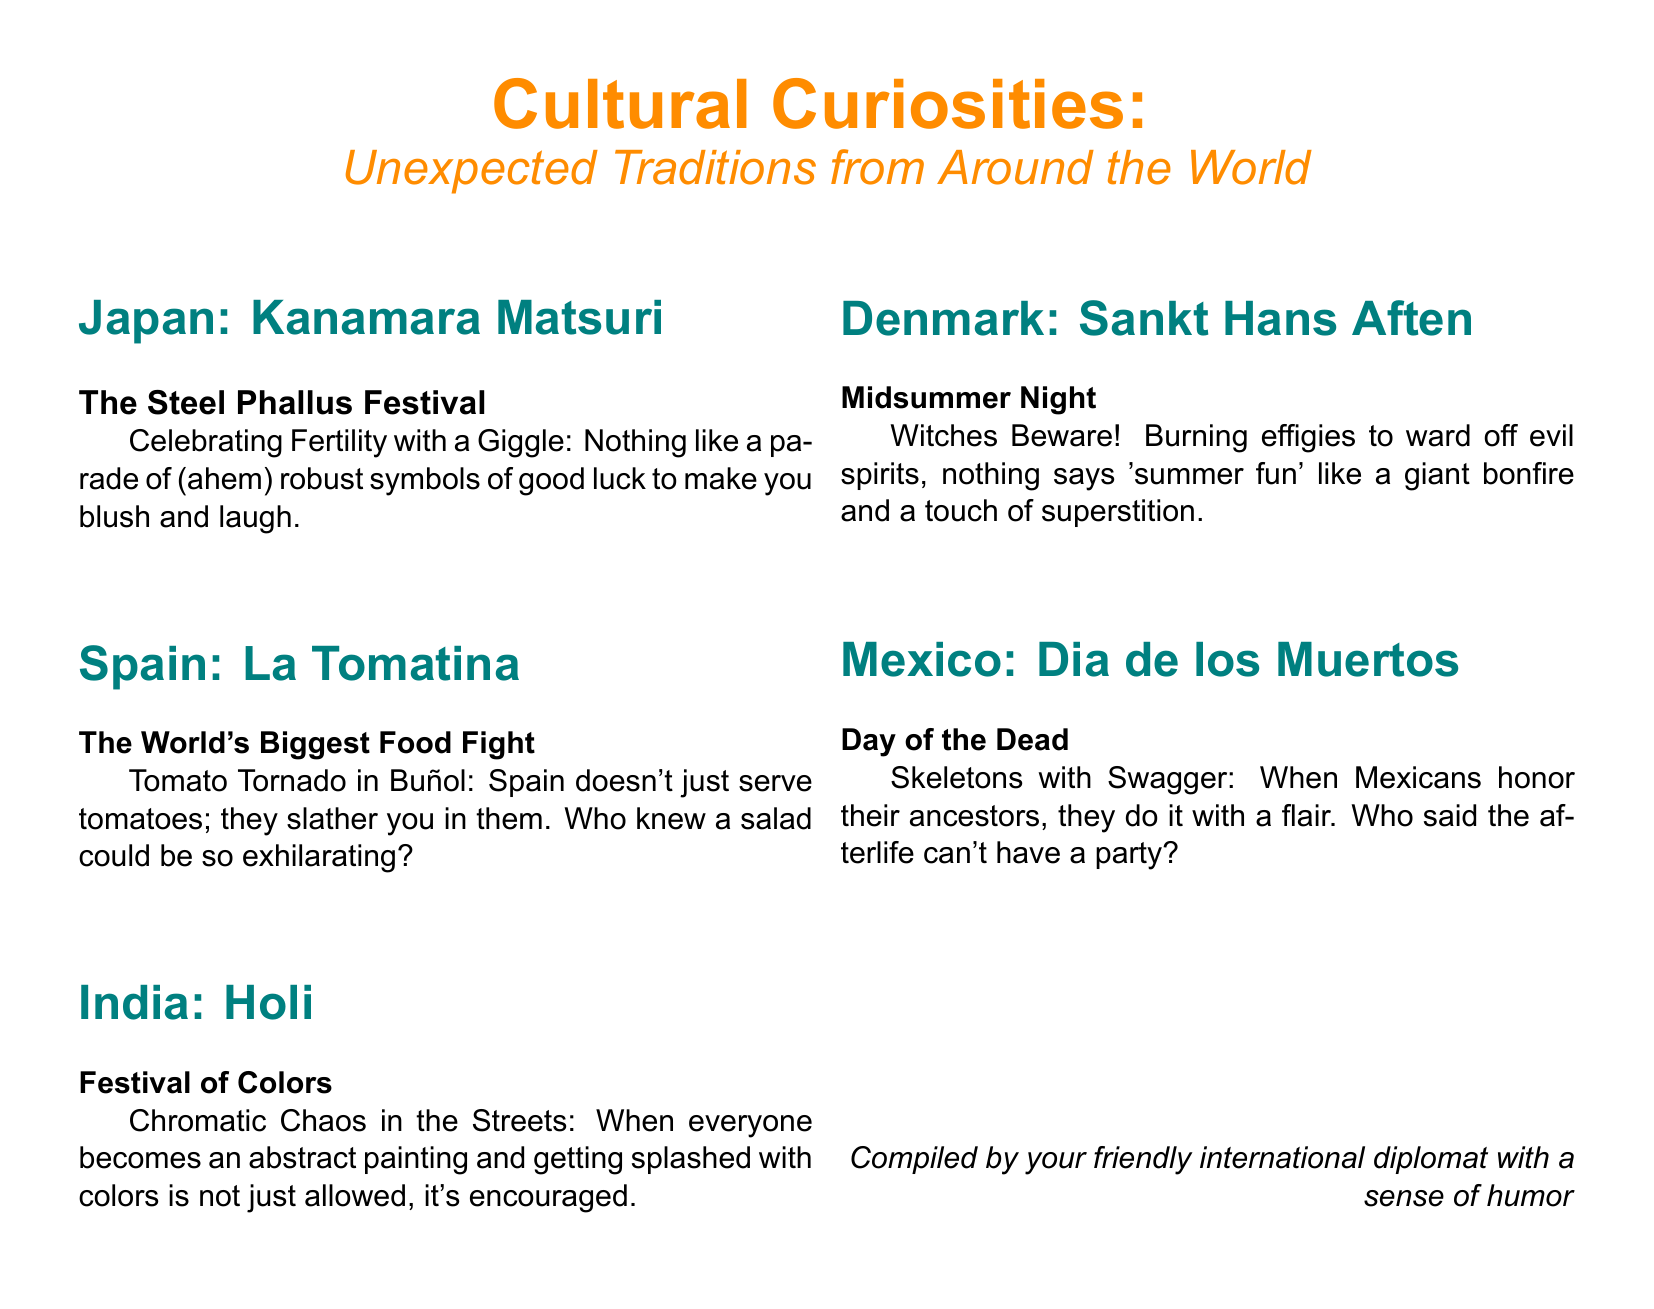What is the title of the feature in the magazine? The title of the feature is prominently displayed at the top of the document.
Answer: Cultural Curiosities: Unexpected Traditions from Around the World How many sections are there in the document? Each cultural curiosity is listed in its own section, and there are five sections total.
Answer: Five What is the theme of the festival Kanamara Matsuri in Japan? The theme of the festival is reflected in its subtitle, which gives insight into the nature of the celebration.
Answer: Fertility Which country's tradition involves a giant food fight? The document specifies the country where the tradition occurs in the title of the section.
Answer: Spain What is the main purpose of the Dia de los Muertos celebration? The nature of the celebration is elaborated in its descriptive text within the document.
Answer: To honor ancestors Which phrase describes the purpose of burning effigies during Sankt Hans Aften in Denmark? The document explicitly states the intent behind this practice in a playful manner.
Answer: To ward off evil spirits What type of imagery would you expect to see in the Holi festival section? The event's description suggests a lively scene characterized by colors and vibrancy.
Answer: Chromatic Chaos What humorous element does the title "Skeletons with Swagger" suggest about Dia de los Muertos? The title employs a playful expression, hinting at a festive atmosphere during the celebration.
Answer: Humor What was the intention behind the Kanamara Matsuri festival? The document mentions what the festival symbolizes, highlighting its thematic focus.
Answer: Good luck 